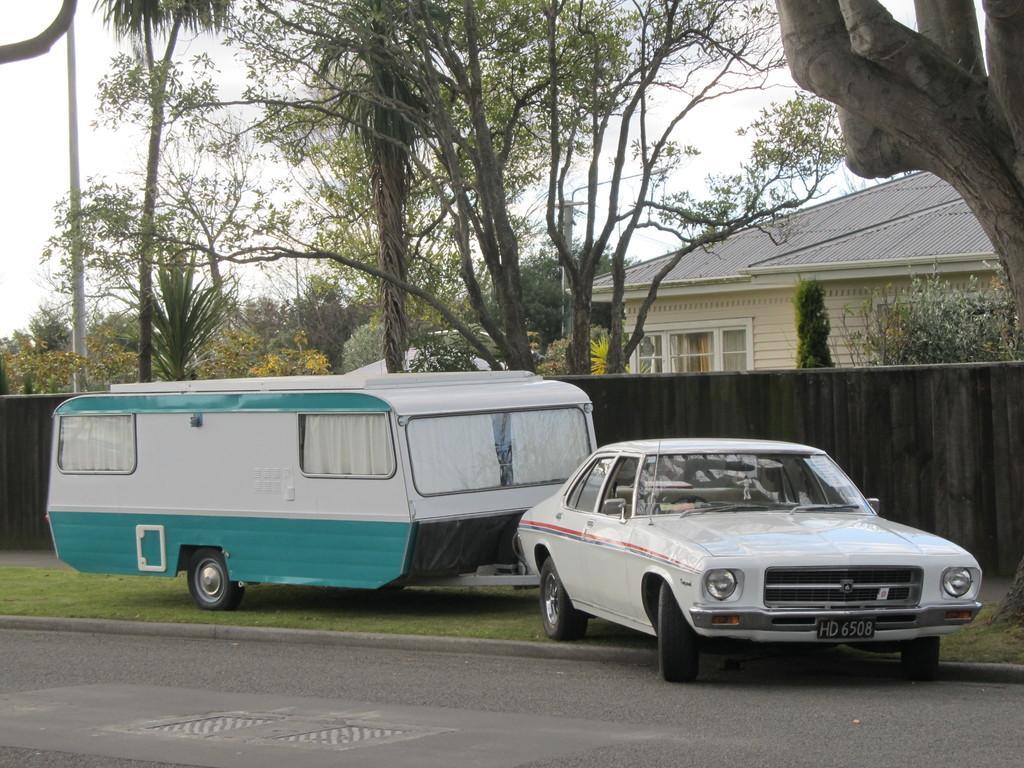Describe this image in one or two sentences. There is a white color vehicle which is partially on the road near other vehicle which is grass on the ground, near a wall and a tree. In the background, there is a building which is having roof and glass windows, there are trees and there is sky. 